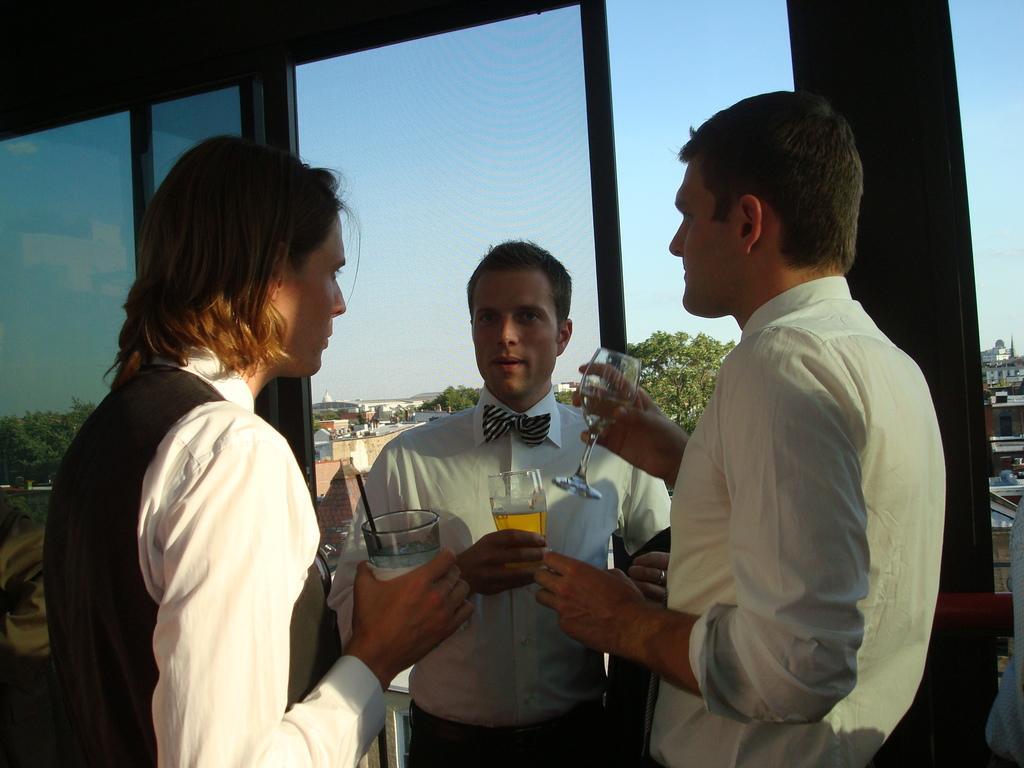Please provide a concise description of this image. In this picture we can see three persons are standing and holding glasses of drinks in the front, in the background there are some buildings and trees, on the left side there is a glass, we can see the sky at the top of the picture. 